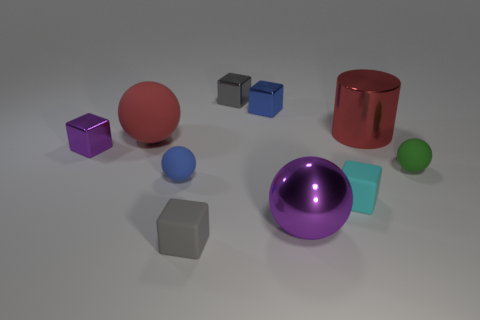Subtract all purple cubes. How many cubes are left? 4 Subtract all cyan blocks. How many blocks are left? 4 Subtract all yellow cubes. Subtract all purple cylinders. How many cubes are left? 5 Subtract all cylinders. How many objects are left? 9 Subtract all purple metallic balls. Subtract all blue metallic things. How many objects are left? 8 Add 7 small purple blocks. How many small purple blocks are left? 8 Add 3 small purple shiny objects. How many small purple shiny objects exist? 4 Subtract 0 brown spheres. How many objects are left? 10 